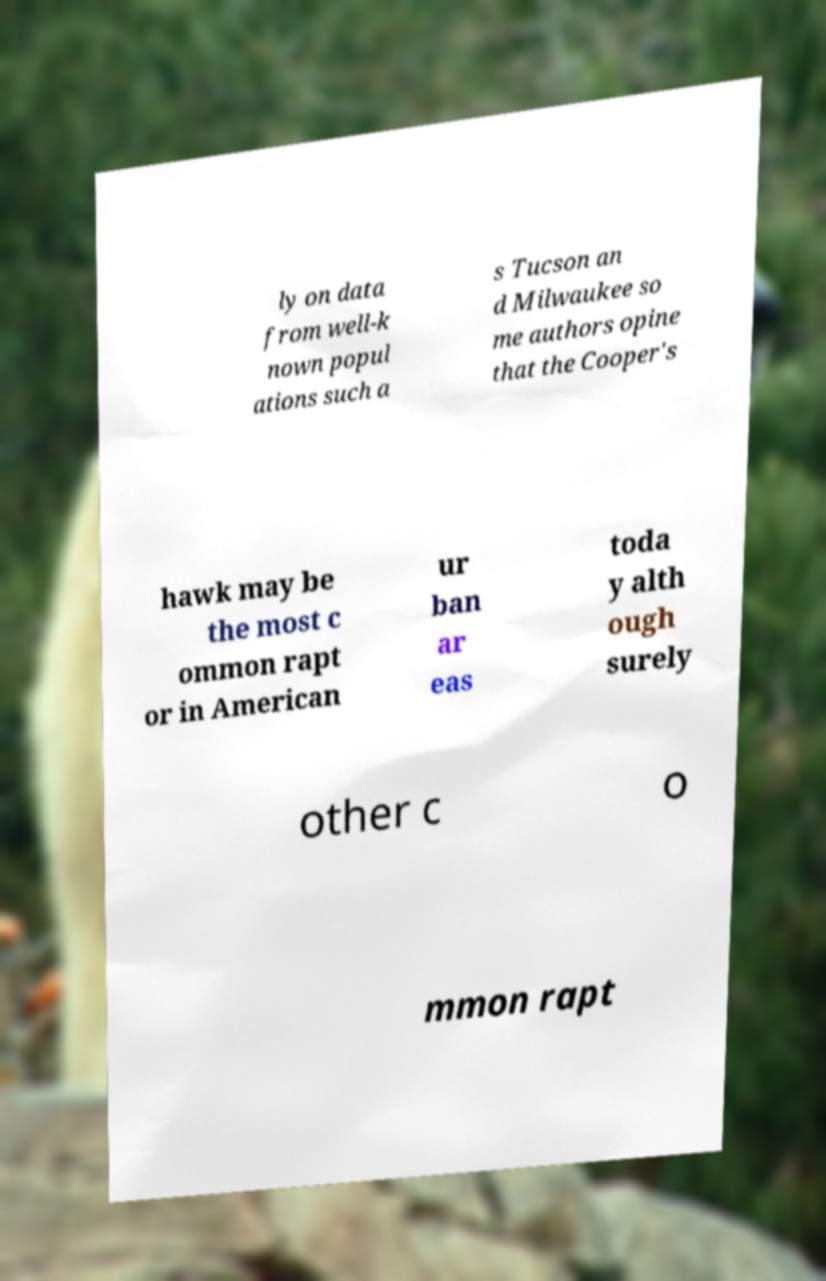Please read and relay the text visible in this image. What does it say? ly on data from well-k nown popul ations such a s Tucson an d Milwaukee so me authors opine that the Cooper's hawk may be the most c ommon rapt or in American ur ban ar eas toda y alth ough surely other c o mmon rapt 